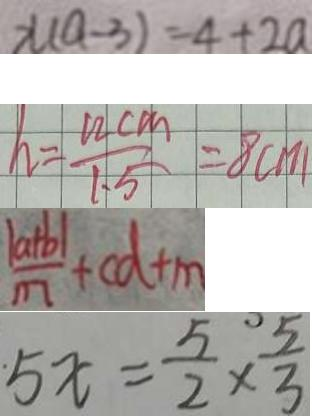<formula> <loc_0><loc_0><loc_500><loc_500>x ( a - 3 ) = 4 + 2 a 
 h = \frac { 1 2 c m } { 1 . 5 } = 8 c m 
 \frac { \vert a + b \vert } { m } + c d + m 
 5 x = \frac { 5 } { 2 } \times \frac { 5 } { 3 }</formula> 